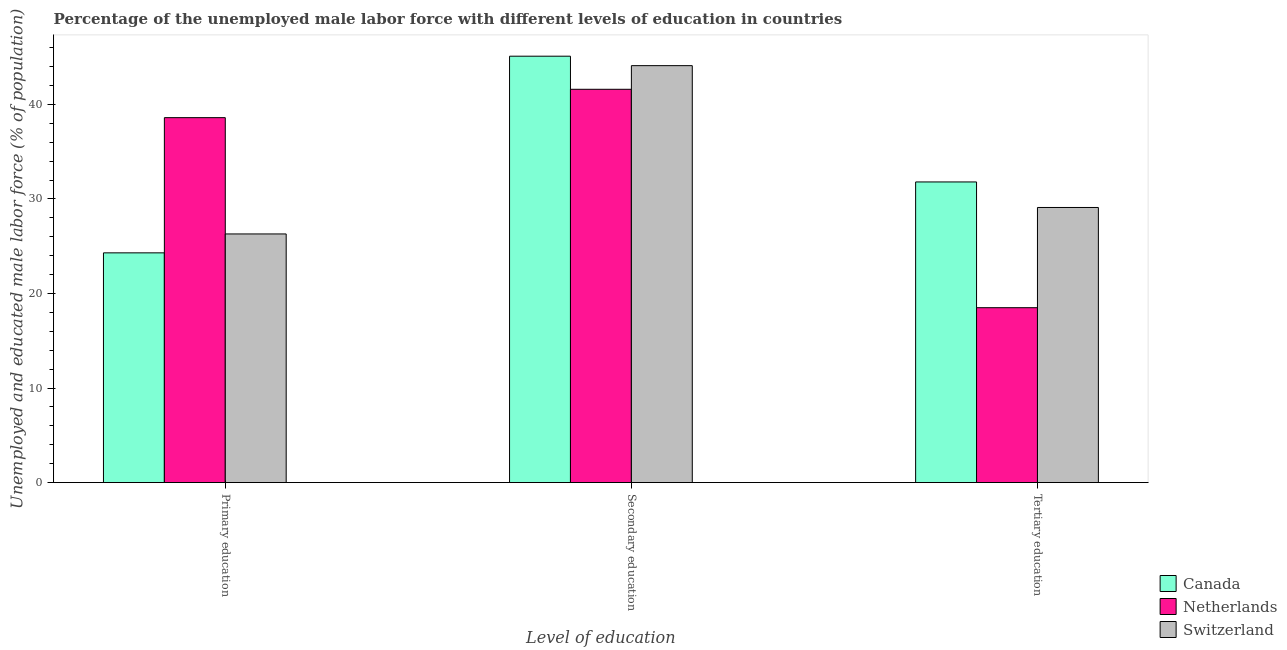How many groups of bars are there?
Make the answer very short. 3. How many bars are there on the 2nd tick from the left?
Keep it short and to the point. 3. How many bars are there on the 1st tick from the right?
Your answer should be very brief. 3. What is the label of the 2nd group of bars from the left?
Ensure brevity in your answer.  Secondary education. What is the percentage of male labor force who received primary education in Netherlands?
Ensure brevity in your answer.  38.6. Across all countries, what is the maximum percentage of male labor force who received tertiary education?
Your answer should be very brief. 31.8. Across all countries, what is the minimum percentage of male labor force who received tertiary education?
Provide a succinct answer. 18.5. What is the total percentage of male labor force who received secondary education in the graph?
Offer a very short reply. 130.8. What is the difference between the percentage of male labor force who received tertiary education in Switzerland and that in Netherlands?
Ensure brevity in your answer.  10.6. What is the difference between the percentage of male labor force who received tertiary education in Canada and the percentage of male labor force who received secondary education in Switzerland?
Make the answer very short. -12.3. What is the average percentage of male labor force who received secondary education per country?
Your answer should be compact. 43.6. What is the difference between the percentage of male labor force who received primary education and percentage of male labor force who received secondary education in Canada?
Your answer should be very brief. -20.8. In how many countries, is the percentage of male labor force who received secondary education greater than 26 %?
Provide a short and direct response. 3. What is the ratio of the percentage of male labor force who received secondary education in Canada to that in Switzerland?
Offer a terse response. 1.02. Is the percentage of male labor force who received tertiary education in Netherlands less than that in Canada?
Provide a short and direct response. Yes. What is the difference between the highest and the second highest percentage of male labor force who received tertiary education?
Offer a very short reply. 2.7. What does the 2nd bar from the left in Primary education represents?
Provide a short and direct response. Netherlands. How many legend labels are there?
Provide a succinct answer. 3. How are the legend labels stacked?
Make the answer very short. Vertical. What is the title of the graph?
Your answer should be compact. Percentage of the unemployed male labor force with different levels of education in countries. Does "Bulgaria" appear as one of the legend labels in the graph?
Your response must be concise. No. What is the label or title of the X-axis?
Ensure brevity in your answer.  Level of education. What is the label or title of the Y-axis?
Your response must be concise. Unemployed and educated male labor force (% of population). What is the Unemployed and educated male labor force (% of population) in Canada in Primary education?
Provide a succinct answer. 24.3. What is the Unemployed and educated male labor force (% of population) in Netherlands in Primary education?
Give a very brief answer. 38.6. What is the Unemployed and educated male labor force (% of population) of Switzerland in Primary education?
Provide a short and direct response. 26.3. What is the Unemployed and educated male labor force (% of population) of Canada in Secondary education?
Ensure brevity in your answer.  45.1. What is the Unemployed and educated male labor force (% of population) of Netherlands in Secondary education?
Offer a very short reply. 41.6. What is the Unemployed and educated male labor force (% of population) in Switzerland in Secondary education?
Give a very brief answer. 44.1. What is the Unemployed and educated male labor force (% of population) in Canada in Tertiary education?
Provide a short and direct response. 31.8. What is the Unemployed and educated male labor force (% of population) in Netherlands in Tertiary education?
Offer a terse response. 18.5. What is the Unemployed and educated male labor force (% of population) in Switzerland in Tertiary education?
Your response must be concise. 29.1. Across all Level of education, what is the maximum Unemployed and educated male labor force (% of population) in Canada?
Your response must be concise. 45.1. Across all Level of education, what is the maximum Unemployed and educated male labor force (% of population) in Netherlands?
Give a very brief answer. 41.6. Across all Level of education, what is the maximum Unemployed and educated male labor force (% of population) of Switzerland?
Ensure brevity in your answer.  44.1. Across all Level of education, what is the minimum Unemployed and educated male labor force (% of population) of Canada?
Keep it short and to the point. 24.3. Across all Level of education, what is the minimum Unemployed and educated male labor force (% of population) in Netherlands?
Give a very brief answer. 18.5. Across all Level of education, what is the minimum Unemployed and educated male labor force (% of population) of Switzerland?
Give a very brief answer. 26.3. What is the total Unemployed and educated male labor force (% of population) in Canada in the graph?
Provide a succinct answer. 101.2. What is the total Unemployed and educated male labor force (% of population) in Netherlands in the graph?
Your answer should be compact. 98.7. What is the total Unemployed and educated male labor force (% of population) of Switzerland in the graph?
Your answer should be very brief. 99.5. What is the difference between the Unemployed and educated male labor force (% of population) in Canada in Primary education and that in Secondary education?
Your answer should be compact. -20.8. What is the difference between the Unemployed and educated male labor force (% of population) of Netherlands in Primary education and that in Secondary education?
Keep it short and to the point. -3. What is the difference between the Unemployed and educated male labor force (% of population) in Switzerland in Primary education and that in Secondary education?
Offer a very short reply. -17.8. What is the difference between the Unemployed and educated male labor force (% of population) in Canada in Primary education and that in Tertiary education?
Your answer should be compact. -7.5. What is the difference between the Unemployed and educated male labor force (% of population) in Netherlands in Primary education and that in Tertiary education?
Provide a succinct answer. 20.1. What is the difference between the Unemployed and educated male labor force (% of population) in Netherlands in Secondary education and that in Tertiary education?
Your answer should be compact. 23.1. What is the difference between the Unemployed and educated male labor force (% of population) of Switzerland in Secondary education and that in Tertiary education?
Your answer should be very brief. 15. What is the difference between the Unemployed and educated male labor force (% of population) of Canada in Primary education and the Unemployed and educated male labor force (% of population) of Netherlands in Secondary education?
Provide a succinct answer. -17.3. What is the difference between the Unemployed and educated male labor force (% of population) of Canada in Primary education and the Unemployed and educated male labor force (% of population) of Switzerland in Secondary education?
Give a very brief answer. -19.8. What is the difference between the Unemployed and educated male labor force (% of population) in Canada in Primary education and the Unemployed and educated male labor force (% of population) in Netherlands in Tertiary education?
Your response must be concise. 5.8. What is the difference between the Unemployed and educated male labor force (% of population) in Canada in Primary education and the Unemployed and educated male labor force (% of population) in Switzerland in Tertiary education?
Offer a terse response. -4.8. What is the difference between the Unemployed and educated male labor force (% of population) of Canada in Secondary education and the Unemployed and educated male labor force (% of population) of Netherlands in Tertiary education?
Your answer should be very brief. 26.6. What is the average Unemployed and educated male labor force (% of population) in Canada per Level of education?
Your response must be concise. 33.73. What is the average Unemployed and educated male labor force (% of population) of Netherlands per Level of education?
Your response must be concise. 32.9. What is the average Unemployed and educated male labor force (% of population) in Switzerland per Level of education?
Offer a terse response. 33.17. What is the difference between the Unemployed and educated male labor force (% of population) of Canada and Unemployed and educated male labor force (% of population) of Netherlands in Primary education?
Keep it short and to the point. -14.3. What is the difference between the Unemployed and educated male labor force (% of population) in Netherlands and Unemployed and educated male labor force (% of population) in Switzerland in Secondary education?
Offer a terse response. -2.5. What is the difference between the Unemployed and educated male labor force (% of population) in Netherlands and Unemployed and educated male labor force (% of population) in Switzerland in Tertiary education?
Offer a very short reply. -10.6. What is the ratio of the Unemployed and educated male labor force (% of population) in Canada in Primary education to that in Secondary education?
Offer a very short reply. 0.54. What is the ratio of the Unemployed and educated male labor force (% of population) of Netherlands in Primary education to that in Secondary education?
Keep it short and to the point. 0.93. What is the ratio of the Unemployed and educated male labor force (% of population) of Switzerland in Primary education to that in Secondary education?
Offer a very short reply. 0.6. What is the ratio of the Unemployed and educated male labor force (% of population) in Canada in Primary education to that in Tertiary education?
Your answer should be very brief. 0.76. What is the ratio of the Unemployed and educated male labor force (% of population) in Netherlands in Primary education to that in Tertiary education?
Provide a succinct answer. 2.09. What is the ratio of the Unemployed and educated male labor force (% of population) of Switzerland in Primary education to that in Tertiary education?
Make the answer very short. 0.9. What is the ratio of the Unemployed and educated male labor force (% of population) of Canada in Secondary education to that in Tertiary education?
Your response must be concise. 1.42. What is the ratio of the Unemployed and educated male labor force (% of population) of Netherlands in Secondary education to that in Tertiary education?
Ensure brevity in your answer.  2.25. What is the ratio of the Unemployed and educated male labor force (% of population) in Switzerland in Secondary education to that in Tertiary education?
Your answer should be compact. 1.52. What is the difference between the highest and the second highest Unemployed and educated male labor force (% of population) of Switzerland?
Your response must be concise. 15. What is the difference between the highest and the lowest Unemployed and educated male labor force (% of population) in Canada?
Provide a short and direct response. 20.8. What is the difference between the highest and the lowest Unemployed and educated male labor force (% of population) of Netherlands?
Keep it short and to the point. 23.1. 